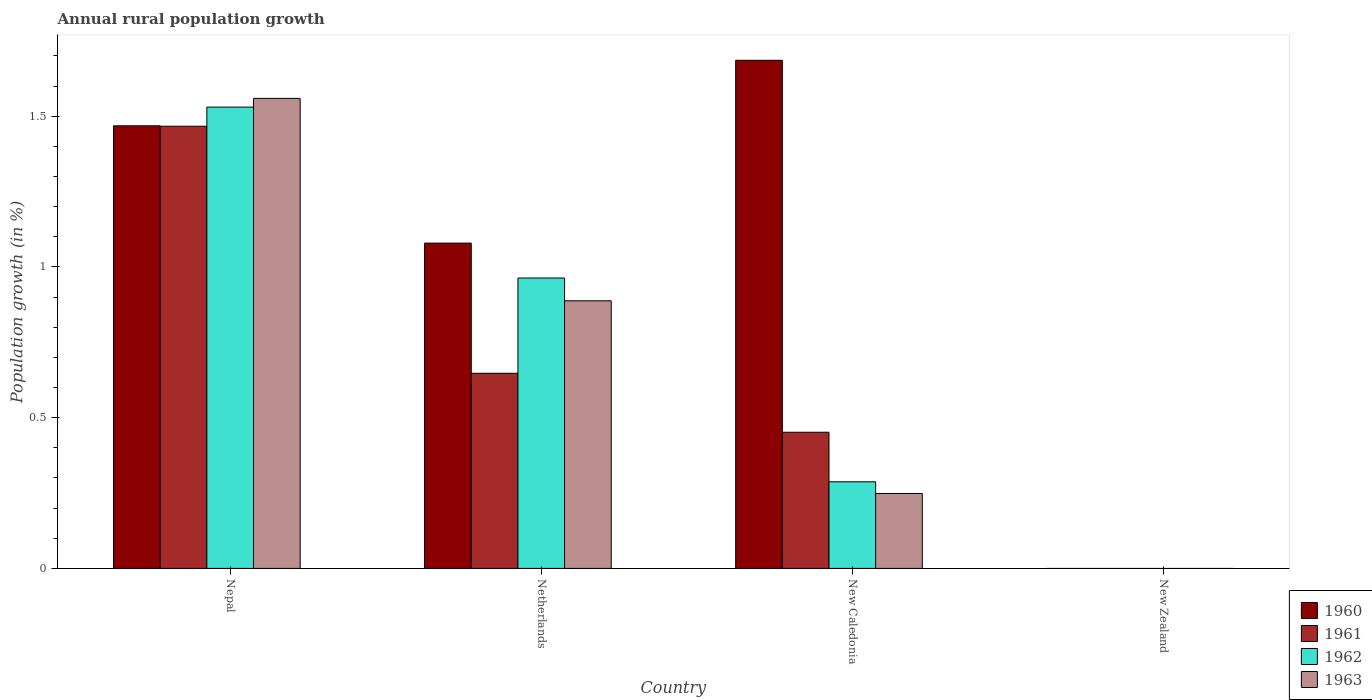How many different coloured bars are there?
Keep it short and to the point. 4. Are the number of bars per tick equal to the number of legend labels?
Keep it short and to the point. No. Are the number of bars on each tick of the X-axis equal?
Your answer should be compact. No. What is the label of the 3rd group of bars from the left?
Offer a very short reply. New Caledonia. In how many cases, is the number of bars for a given country not equal to the number of legend labels?
Offer a very short reply. 1. What is the percentage of rural population growth in 1963 in Netherlands?
Provide a short and direct response. 0.89. Across all countries, what is the maximum percentage of rural population growth in 1961?
Provide a short and direct response. 1.47. In which country was the percentage of rural population growth in 1963 maximum?
Your response must be concise. Nepal. What is the total percentage of rural population growth in 1962 in the graph?
Provide a succinct answer. 2.78. What is the difference between the percentage of rural population growth in 1963 in Nepal and that in New Caledonia?
Offer a very short reply. 1.31. What is the difference between the percentage of rural population growth in 1963 in Netherlands and the percentage of rural population growth in 1960 in New Caledonia?
Ensure brevity in your answer.  -0.8. What is the average percentage of rural population growth in 1962 per country?
Give a very brief answer. 0.7. What is the difference between the percentage of rural population growth of/in 1960 and percentage of rural population growth of/in 1963 in Netherlands?
Offer a very short reply. 0.19. What is the ratio of the percentage of rural population growth in 1962 in Netherlands to that in New Caledonia?
Provide a succinct answer. 3.35. What is the difference between the highest and the second highest percentage of rural population growth in 1962?
Give a very brief answer. -0.57. What is the difference between the highest and the lowest percentage of rural population growth in 1963?
Offer a very short reply. 1.56. In how many countries, is the percentage of rural population growth in 1963 greater than the average percentage of rural population growth in 1963 taken over all countries?
Offer a terse response. 2. Is the sum of the percentage of rural population growth in 1960 in Netherlands and New Caledonia greater than the maximum percentage of rural population growth in 1963 across all countries?
Give a very brief answer. Yes. Is it the case that in every country, the sum of the percentage of rural population growth in 1961 and percentage of rural population growth in 1962 is greater than the sum of percentage of rural population growth in 1963 and percentage of rural population growth in 1960?
Your response must be concise. No. Is it the case that in every country, the sum of the percentage of rural population growth in 1961 and percentage of rural population growth in 1963 is greater than the percentage of rural population growth in 1962?
Provide a short and direct response. No. How many bars are there?
Your response must be concise. 12. Are all the bars in the graph horizontal?
Give a very brief answer. No. How many countries are there in the graph?
Offer a terse response. 4. What is the difference between two consecutive major ticks on the Y-axis?
Give a very brief answer. 0.5. How many legend labels are there?
Keep it short and to the point. 4. How are the legend labels stacked?
Offer a terse response. Vertical. What is the title of the graph?
Provide a short and direct response. Annual rural population growth. What is the label or title of the X-axis?
Make the answer very short. Country. What is the label or title of the Y-axis?
Offer a terse response. Population growth (in %). What is the Population growth (in %) of 1960 in Nepal?
Your response must be concise. 1.47. What is the Population growth (in %) in 1961 in Nepal?
Your answer should be compact. 1.47. What is the Population growth (in %) of 1962 in Nepal?
Your response must be concise. 1.53. What is the Population growth (in %) in 1963 in Nepal?
Your response must be concise. 1.56. What is the Population growth (in %) of 1960 in Netherlands?
Your answer should be compact. 1.08. What is the Population growth (in %) in 1961 in Netherlands?
Your answer should be very brief. 0.65. What is the Population growth (in %) in 1962 in Netherlands?
Your answer should be compact. 0.96. What is the Population growth (in %) in 1963 in Netherlands?
Offer a very short reply. 0.89. What is the Population growth (in %) of 1960 in New Caledonia?
Make the answer very short. 1.69. What is the Population growth (in %) in 1961 in New Caledonia?
Ensure brevity in your answer.  0.45. What is the Population growth (in %) in 1962 in New Caledonia?
Offer a very short reply. 0.29. What is the Population growth (in %) in 1963 in New Caledonia?
Your answer should be compact. 0.25. Across all countries, what is the maximum Population growth (in %) in 1960?
Give a very brief answer. 1.69. Across all countries, what is the maximum Population growth (in %) in 1961?
Your response must be concise. 1.47. Across all countries, what is the maximum Population growth (in %) of 1962?
Keep it short and to the point. 1.53. Across all countries, what is the maximum Population growth (in %) in 1963?
Provide a short and direct response. 1.56. Across all countries, what is the minimum Population growth (in %) of 1962?
Your response must be concise. 0. Across all countries, what is the minimum Population growth (in %) of 1963?
Give a very brief answer. 0. What is the total Population growth (in %) of 1960 in the graph?
Your answer should be compact. 4.23. What is the total Population growth (in %) in 1961 in the graph?
Offer a very short reply. 2.57. What is the total Population growth (in %) in 1962 in the graph?
Provide a short and direct response. 2.78. What is the total Population growth (in %) of 1963 in the graph?
Ensure brevity in your answer.  2.69. What is the difference between the Population growth (in %) of 1960 in Nepal and that in Netherlands?
Make the answer very short. 0.39. What is the difference between the Population growth (in %) in 1961 in Nepal and that in Netherlands?
Give a very brief answer. 0.82. What is the difference between the Population growth (in %) in 1962 in Nepal and that in Netherlands?
Provide a succinct answer. 0.57. What is the difference between the Population growth (in %) in 1963 in Nepal and that in Netherlands?
Provide a succinct answer. 0.67. What is the difference between the Population growth (in %) in 1960 in Nepal and that in New Caledonia?
Your answer should be very brief. -0.22. What is the difference between the Population growth (in %) in 1961 in Nepal and that in New Caledonia?
Offer a very short reply. 1.01. What is the difference between the Population growth (in %) of 1962 in Nepal and that in New Caledonia?
Ensure brevity in your answer.  1.24. What is the difference between the Population growth (in %) of 1963 in Nepal and that in New Caledonia?
Offer a terse response. 1.31. What is the difference between the Population growth (in %) in 1960 in Netherlands and that in New Caledonia?
Offer a terse response. -0.61. What is the difference between the Population growth (in %) in 1961 in Netherlands and that in New Caledonia?
Your response must be concise. 0.2. What is the difference between the Population growth (in %) of 1962 in Netherlands and that in New Caledonia?
Keep it short and to the point. 0.68. What is the difference between the Population growth (in %) of 1963 in Netherlands and that in New Caledonia?
Your answer should be very brief. 0.64. What is the difference between the Population growth (in %) in 1960 in Nepal and the Population growth (in %) in 1961 in Netherlands?
Provide a succinct answer. 0.82. What is the difference between the Population growth (in %) of 1960 in Nepal and the Population growth (in %) of 1962 in Netherlands?
Your answer should be very brief. 0.5. What is the difference between the Population growth (in %) in 1960 in Nepal and the Population growth (in %) in 1963 in Netherlands?
Offer a terse response. 0.58. What is the difference between the Population growth (in %) of 1961 in Nepal and the Population growth (in %) of 1962 in Netherlands?
Give a very brief answer. 0.5. What is the difference between the Population growth (in %) of 1961 in Nepal and the Population growth (in %) of 1963 in Netherlands?
Your response must be concise. 0.58. What is the difference between the Population growth (in %) in 1962 in Nepal and the Population growth (in %) in 1963 in Netherlands?
Provide a succinct answer. 0.64. What is the difference between the Population growth (in %) of 1960 in Nepal and the Population growth (in %) of 1961 in New Caledonia?
Offer a terse response. 1.02. What is the difference between the Population growth (in %) in 1960 in Nepal and the Population growth (in %) in 1962 in New Caledonia?
Your answer should be compact. 1.18. What is the difference between the Population growth (in %) of 1960 in Nepal and the Population growth (in %) of 1963 in New Caledonia?
Provide a succinct answer. 1.22. What is the difference between the Population growth (in %) of 1961 in Nepal and the Population growth (in %) of 1962 in New Caledonia?
Provide a short and direct response. 1.18. What is the difference between the Population growth (in %) of 1961 in Nepal and the Population growth (in %) of 1963 in New Caledonia?
Provide a short and direct response. 1.22. What is the difference between the Population growth (in %) in 1962 in Nepal and the Population growth (in %) in 1963 in New Caledonia?
Your answer should be compact. 1.28. What is the difference between the Population growth (in %) of 1960 in Netherlands and the Population growth (in %) of 1961 in New Caledonia?
Offer a terse response. 0.63. What is the difference between the Population growth (in %) of 1960 in Netherlands and the Population growth (in %) of 1962 in New Caledonia?
Ensure brevity in your answer.  0.79. What is the difference between the Population growth (in %) of 1960 in Netherlands and the Population growth (in %) of 1963 in New Caledonia?
Make the answer very short. 0.83. What is the difference between the Population growth (in %) in 1961 in Netherlands and the Population growth (in %) in 1962 in New Caledonia?
Keep it short and to the point. 0.36. What is the difference between the Population growth (in %) of 1961 in Netherlands and the Population growth (in %) of 1963 in New Caledonia?
Offer a very short reply. 0.4. What is the difference between the Population growth (in %) in 1962 in Netherlands and the Population growth (in %) in 1963 in New Caledonia?
Your response must be concise. 0.71. What is the average Population growth (in %) of 1960 per country?
Provide a succinct answer. 1.06. What is the average Population growth (in %) in 1961 per country?
Your answer should be compact. 0.64. What is the average Population growth (in %) in 1962 per country?
Offer a terse response. 0.7. What is the average Population growth (in %) in 1963 per country?
Make the answer very short. 0.67. What is the difference between the Population growth (in %) in 1960 and Population growth (in %) in 1961 in Nepal?
Offer a very short reply. 0. What is the difference between the Population growth (in %) in 1960 and Population growth (in %) in 1962 in Nepal?
Give a very brief answer. -0.06. What is the difference between the Population growth (in %) in 1960 and Population growth (in %) in 1963 in Nepal?
Your answer should be compact. -0.09. What is the difference between the Population growth (in %) of 1961 and Population growth (in %) of 1962 in Nepal?
Your response must be concise. -0.06. What is the difference between the Population growth (in %) of 1961 and Population growth (in %) of 1963 in Nepal?
Give a very brief answer. -0.09. What is the difference between the Population growth (in %) of 1962 and Population growth (in %) of 1963 in Nepal?
Provide a succinct answer. -0.03. What is the difference between the Population growth (in %) in 1960 and Population growth (in %) in 1961 in Netherlands?
Your answer should be compact. 0.43. What is the difference between the Population growth (in %) in 1960 and Population growth (in %) in 1962 in Netherlands?
Keep it short and to the point. 0.12. What is the difference between the Population growth (in %) of 1960 and Population growth (in %) of 1963 in Netherlands?
Provide a succinct answer. 0.19. What is the difference between the Population growth (in %) in 1961 and Population growth (in %) in 1962 in Netherlands?
Ensure brevity in your answer.  -0.32. What is the difference between the Population growth (in %) in 1961 and Population growth (in %) in 1963 in Netherlands?
Ensure brevity in your answer.  -0.24. What is the difference between the Population growth (in %) of 1962 and Population growth (in %) of 1963 in Netherlands?
Offer a terse response. 0.08. What is the difference between the Population growth (in %) in 1960 and Population growth (in %) in 1961 in New Caledonia?
Your response must be concise. 1.23. What is the difference between the Population growth (in %) in 1960 and Population growth (in %) in 1962 in New Caledonia?
Your response must be concise. 1.4. What is the difference between the Population growth (in %) of 1960 and Population growth (in %) of 1963 in New Caledonia?
Your response must be concise. 1.44. What is the difference between the Population growth (in %) of 1961 and Population growth (in %) of 1962 in New Caledonia?
Your answer should be very brief. 0.16. What is the difference between the Population growth (in %) of 1961 and Population growth (in %) of 1963 in New Caledonia?
Provide a succinct answer. 0.2. What is the difference between the Population growth (in %) in 1962 and Population growth (in %) in 1963 in New Caledonia?
Offer a terse response. 0.04. What is the ratio of the Population growth (in %) in 1960 in Nepal to that in Netherlands?
Provide a succinct answer. 1.36. What is the ratio of the Population growth (in %) in 1961 in Nepal to that in Netherlands?
Keep it short and to the point. 2.27. What is the ratio of the Population growth (in %) of 1962 in Nepal to that in Netherlands?
Your answer should be compact. 1.59. What is the ratio of the Population growth (in %) in 1963 in Nepal to that in Netherlands?
Make the answer very short. 1.76. What is the ratio of the Population growth (in %) in 1960 in Nepal to that in New Caledonia?
Your response must be concise. 0.87. What is the ratio of the Population growth (in %) in 1961 in Nepal to that in New Caledonia?
Provide a succinct answer. 3.25. What is the ratio of the Population growth (in %) in 1962 in Nepal to that in New Caledonia?
Provide a succinct answer. 5.33. What is the ratio of the Population growth (in %) of 1963 in Nepal to that in New Caledonia?
Your answer should be compact. 6.28. What is the ratio of the Population growth (in %) of 1960 in Netherlands to that in New Caledonia?
Your response must be concise. 0.64. What is the ratio of the Population growth (in %) in 1961 in Netherlands to that in New Caledonia?
Keep it short and to the point. 1.43. What is the ratio of the Population growth (in %) in 1962 in Netherlands to that in New Caledonia?
Keep it short and to the point. 3.35. What is the ratio of the Population growth (in %) in 1963 in Netherlands to that in New Caledonia?
Your response must be concise. 3.57. What is the difference between the highest and the second highest Population growth (in %) in 1960?
Your response must be concise. 0.22. What is the difference between the highest and the second highest Population growth (in %) of 1961?
Your answer should be very brief. 0.82. What is the difference between the highest and the second highest Population growth (in %) of 1962?
Ensure brevity in your answer.  0.57. What is the difference between the highest and the second highest Population growth (in %) of 1963?
Provide a short and direct response. 0.67. What is the difference between the highest and the lowest Population growth (in %) of 1960?
Your response must be concise. 1.69. What is the difference between the highest and the lowest Population growth (in %) of 1961?
Your response must be concise. 1.47. What is the difference between the highest and the lowest Population growth (in %) in 1962?
Your answer should be compact. 1.53. What is the difference between the highest and the lowest Population growth (in %) of 1963?
Your answer should be very brief. 1.56. 